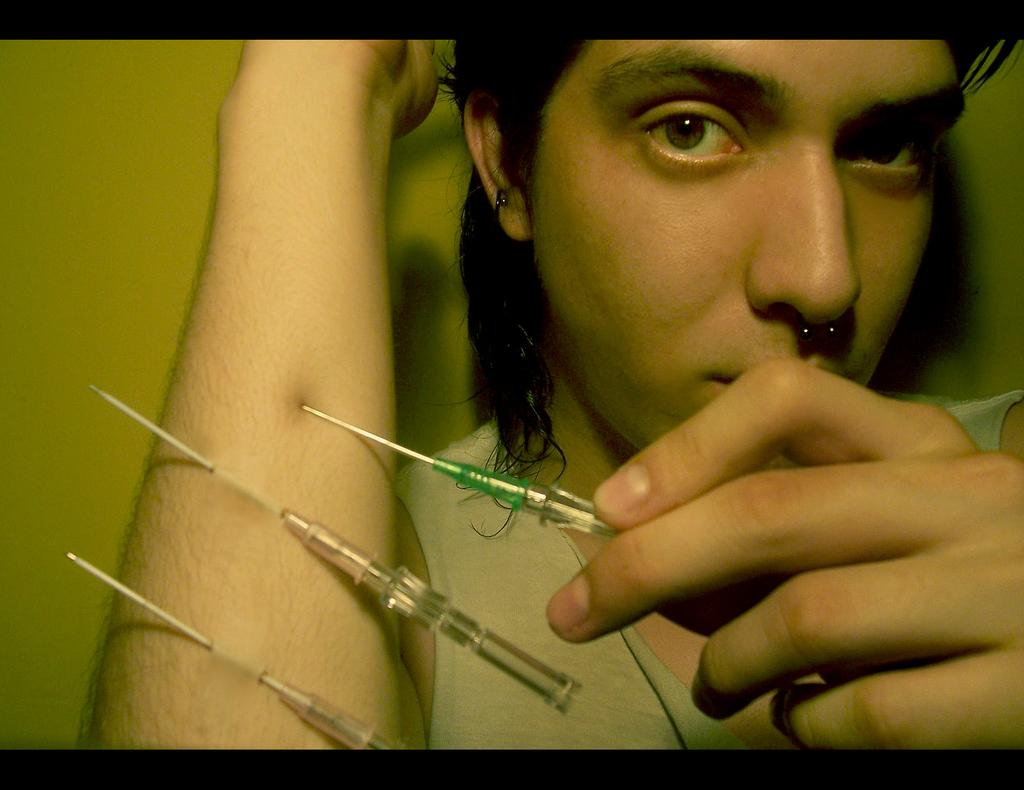What is the main subject of the image? There is a person in the image. What objects can be seen near the person? There are syringes in the image. Can you describe the background of the image? The background of the image is blurry. How does the judge use the brake in the image? There is no judge or brake present in the image. What type of steam is visible coming from the person in the image? There is no steam visible in the image. 